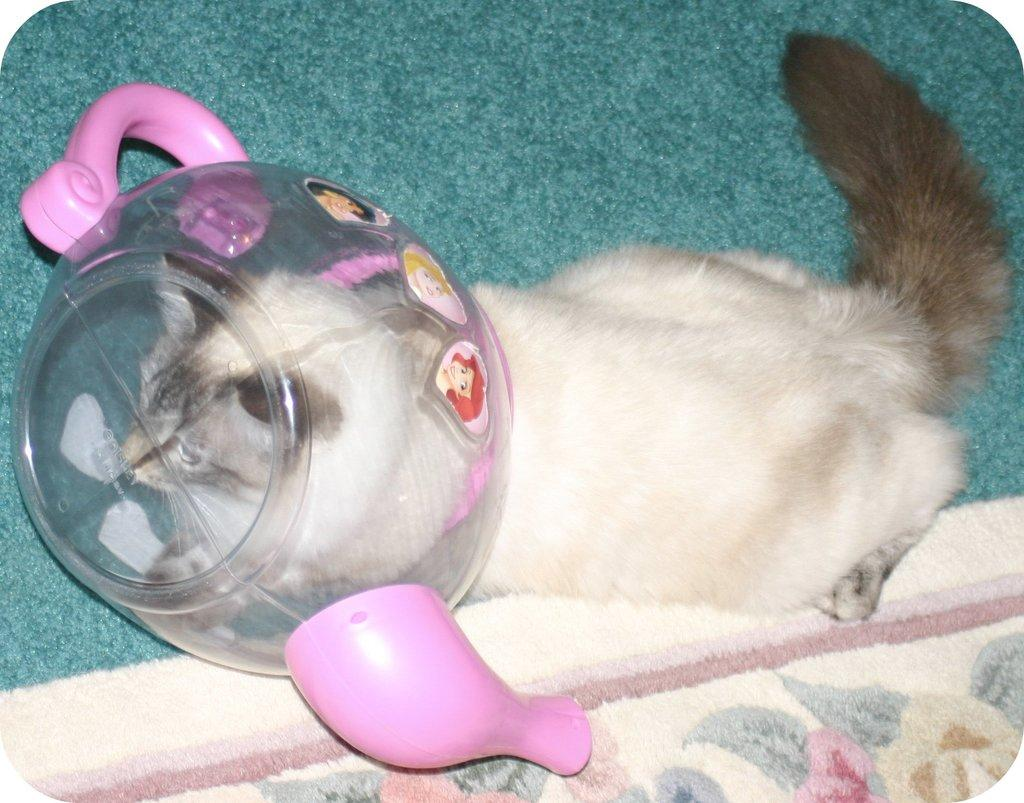What type of animal is in the image? There is a cat in the image. What is the cat doing in the image? The cat's head is inside a plastic jar. Can you describe the color of the cat? The cat is white and black in color. What type of flooring is visible in the image? There are carpets visible in the image. What type of silk is being used to create the thunder in the image? There is no silk or thunder present in the image; it features a cat with its head inside a plastic jar and carpets visible on the floor. 